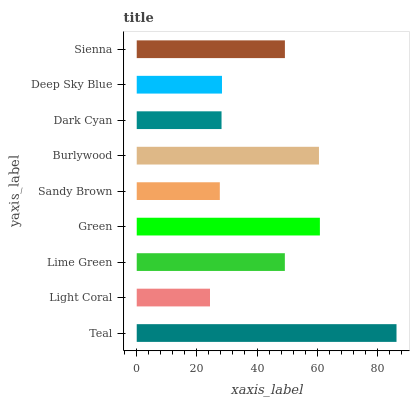Is Light Coral the minimum?
Answer yes or no. Yes. Is Teal the maximum?
Answer yes or no. Yes. Is Lime Green the minimum?
Answer yes or no. No. Is Lime Green the maximum?
Answer yes or no. No. Is Lime Green greater than Light Coral?
Answer yes or no. Yes. Is Light Coral less than Lime Green?
Answer yes or no. Yes. Is Light Coral greater than Lime Green?
Answer yes or no. No. Is Lime Green less than Light Coral?
Answer yes or no. No. Is Lime Green the high median?
Answer yes or no. Yes. Is Lime Green the low median?
Answer yes or no. Yes. Is Sandy Brown the high median?
Answer yes or no. No. Is Light Coral the low median?
Answer yes or no. No. 